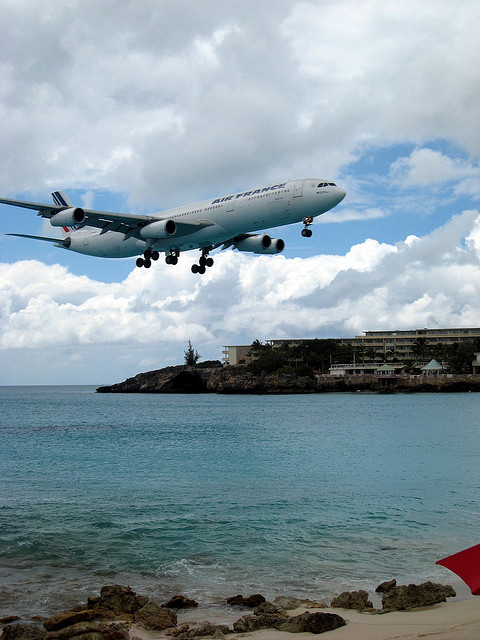Please transcribe the text in this image. AIR FRANCE 